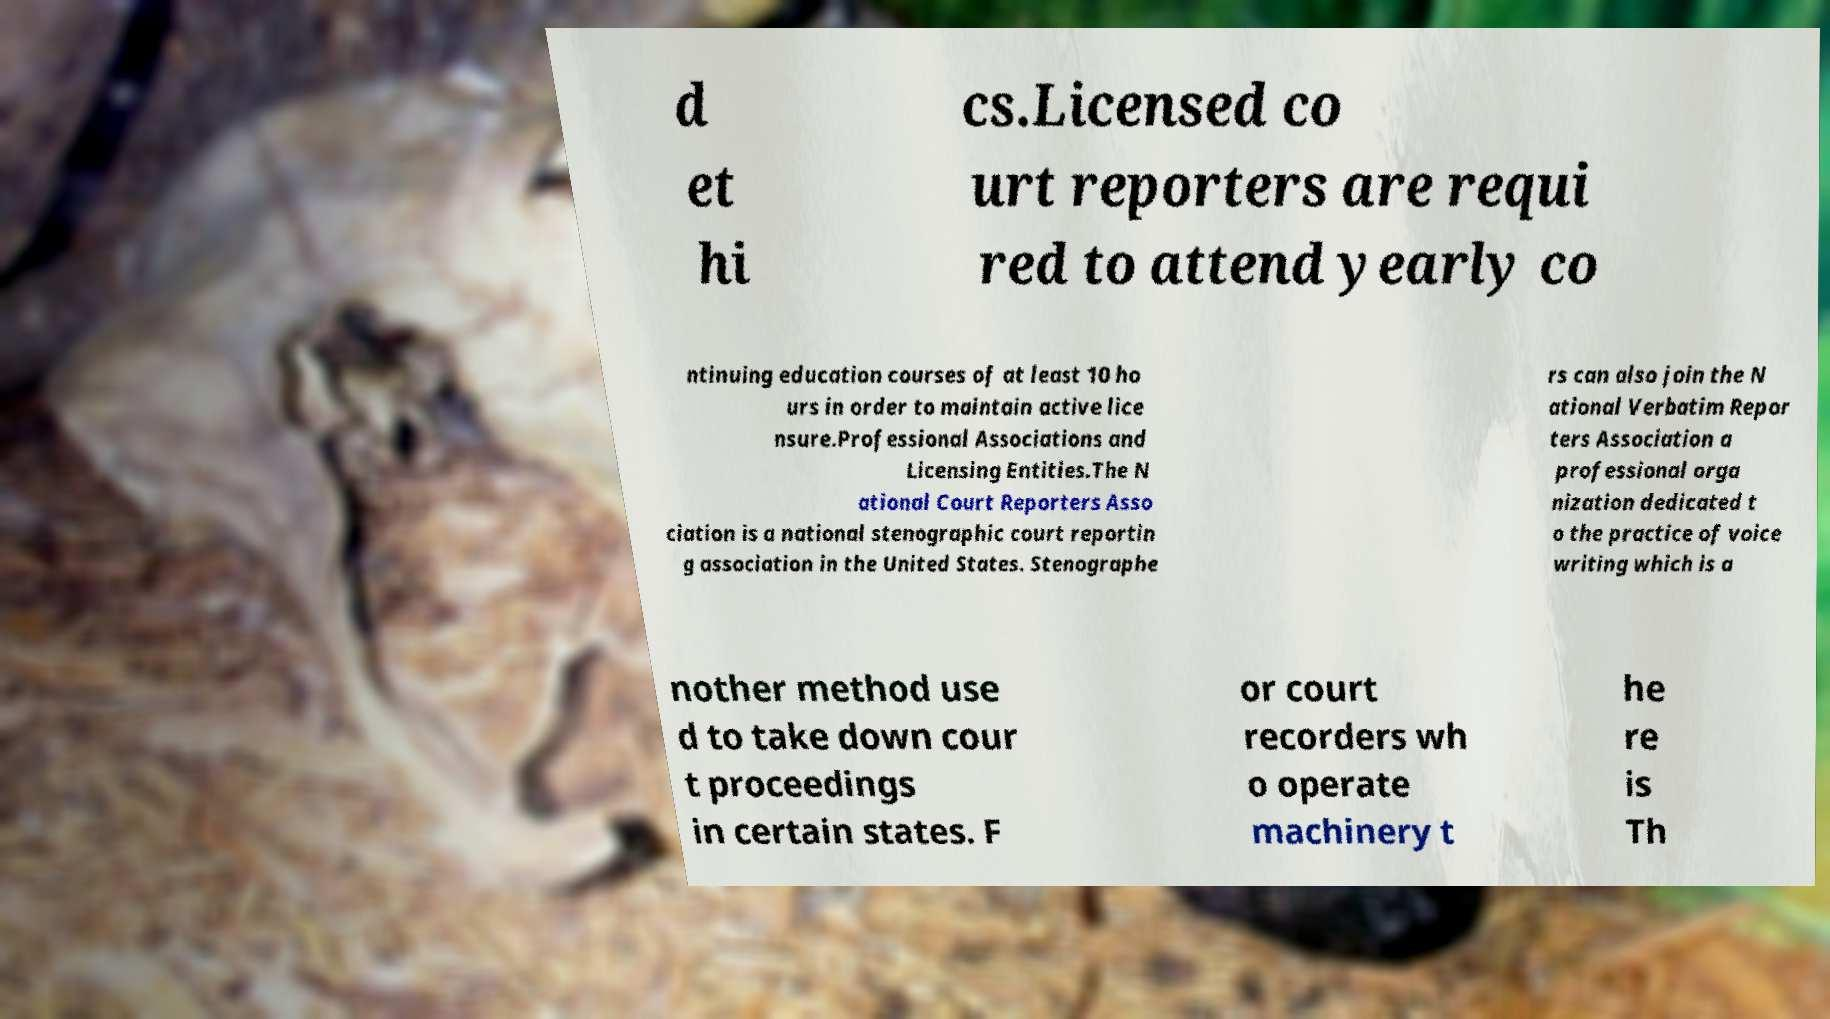Could you assist in decoding the text presented in this image and type it out clearly? d et hi cs.Licensed co urt reporters are requi red to attend yearly co ntinuing education courses of at least 10 ho urs in order to maintain active lice nsure.Professional Associations and Licensing Entities.The N ational Court Reporters Asso ciation is a national stenographic court reportin g association in the United States. Stenographe rs can also join the N ational Verbatim Repor ters Association a professional orga nization dedicated t o the practice of voice writing which is a nother method use d to take down cour t proceedings in certain states. F or court recorders wh o operate machinery t he re is Th 